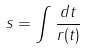Convert formula to latex. <formula><loc_0><loc_0><loc_500><loc_500>s = \int \frac { d t } { r ( t ) }</formula> 